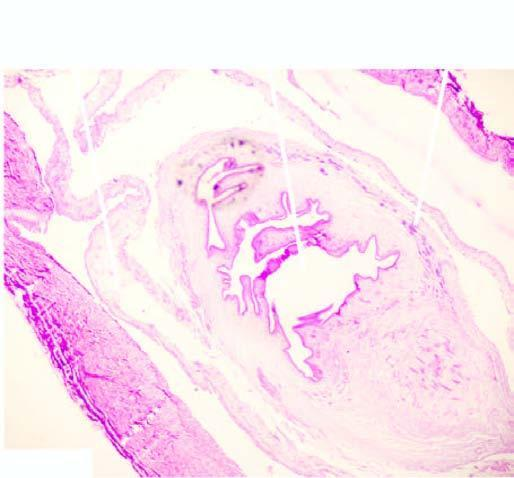does sectioned slice of the liver show palisade layer of histiocytes?
Answer the question using a single word or phrase. No 